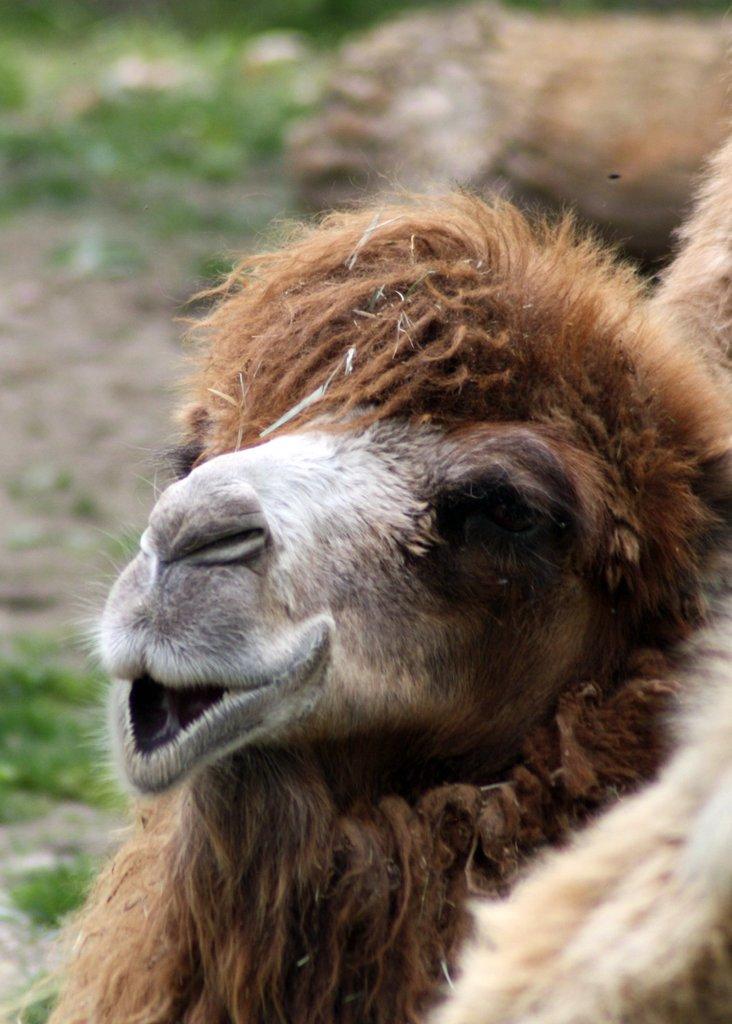Can you describe this image briefly? There is a camel and the background is blurred. 